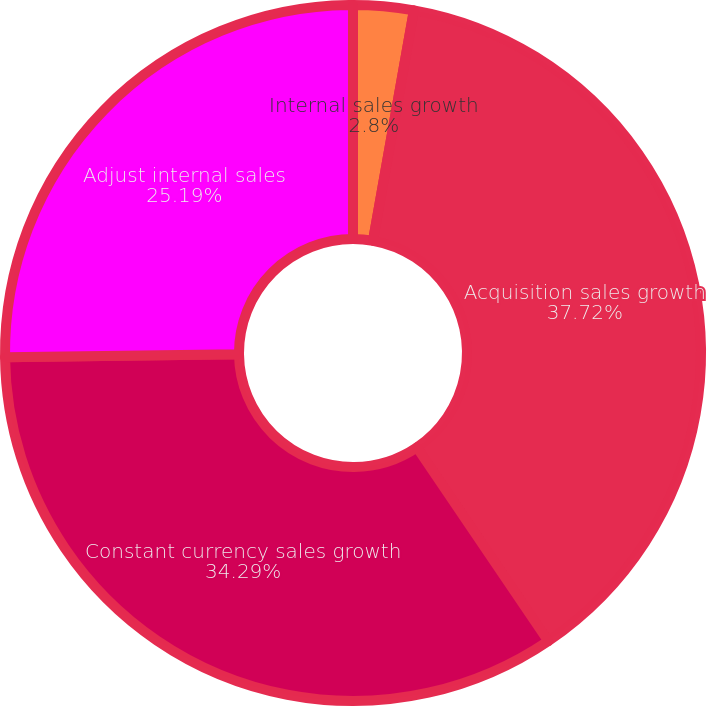Convert chart. <chart><loc_0><loc_0><loc_500><loc_500><pie_chart><fcel>Internal sales growth<fcel>Acquisition sales growth<fcel>Constant currency sales growth<fcel>Adjust internal sales<nl><fcel>2.8%<fcel>37.72%<fcel>34.29%<fcel>25.19%<nl></chart> 